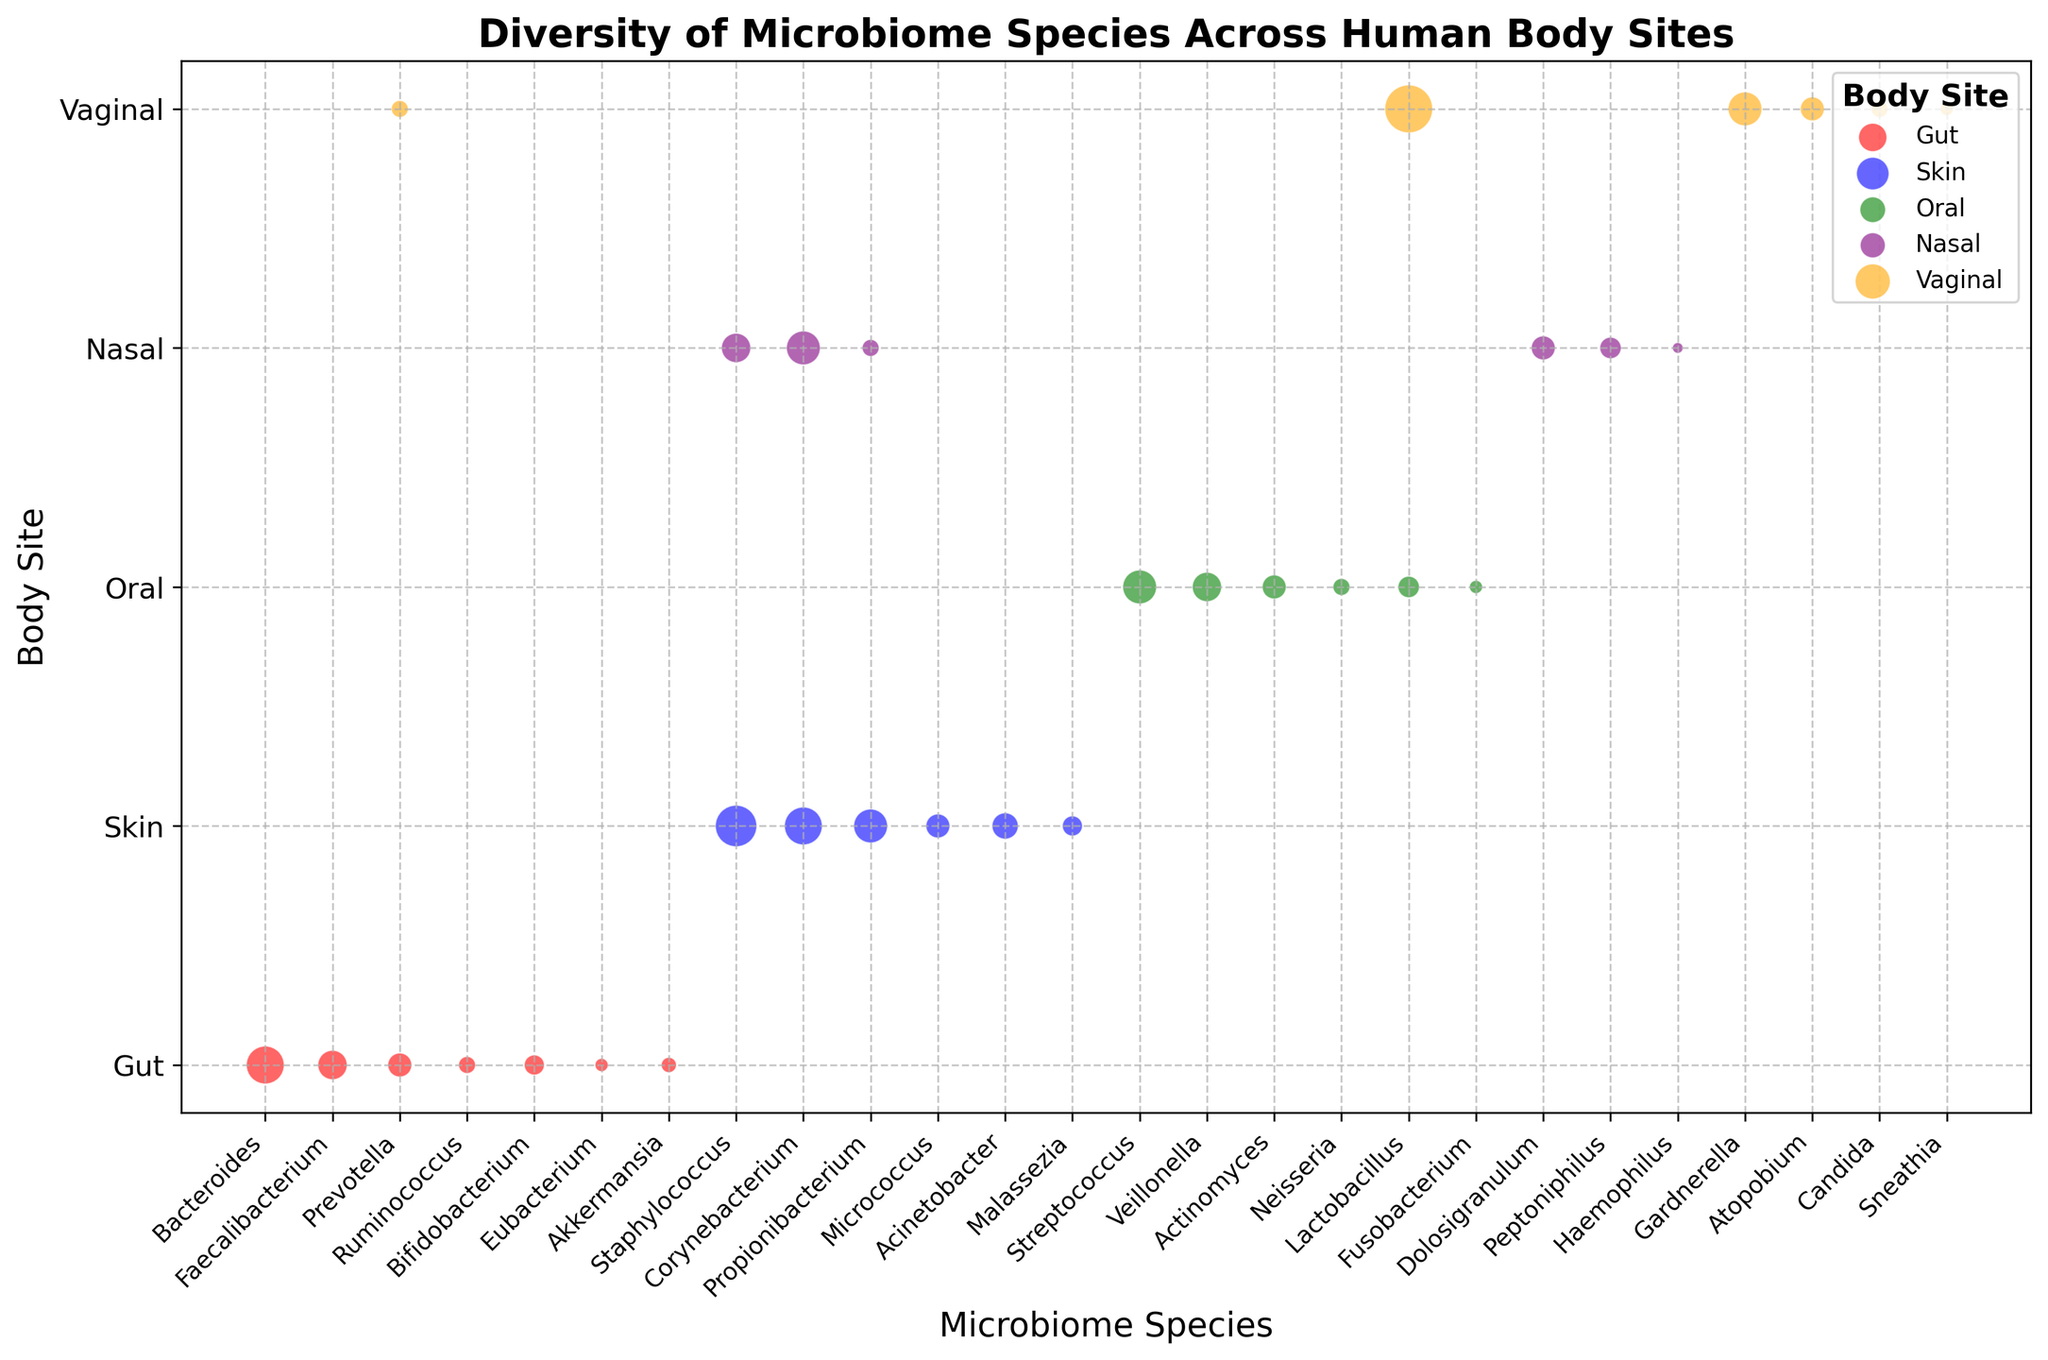What is the microbiome species with the highest relative abundance in the vaginal site? To find the microbiome species with the highest relative abundance in the vaginal site, check the vaginal site on the y-axis and compare the size of the bubbles. Lactobacillus has the largest bubble.
Answer: Lactobacillus Which body site has the most diversity in microbiome species, and how can you tell? Look at the number of different microbiome species listed for each body site on the y-axis. The Gut has the most unique labels, indicating the highest diversity.
Answer: Gut Compare the relative abundance of Staphylococcus in the nasal and skin sites. Which has a higher relative abundance and by how much? Find the bubbles for Staphylococcus in both the nasal and skin sites. The size of the bubble in the skin site (30%) is larger than in the nasal site (15%). The difference is 30% - 15% = 15%.
Answer: Skin by 15% What is the average relative abundance of Propionibacterium across all body sites it appears in? Check the relative abundance of Propionibacterium in each body site (skin and nasal). Sum these values and divide by the number of instances: (20% + 5%) / 2 = 12.5%.
Answer: 12.5% Which body site has the smallest range of relative abundance among its microbiome species? Calculate the range of relative abundance (max - min) for each body site, then compare. For the nasal site, the relative abundance ranges from 2% to 20%, the smallest range of 18%.
Answer: Nasal How does the relative abundance of Faecalibacterium in the gut compare to Veillonella in the oral site? Check the size of the bubbles for Faecalibacterium in the gut (15%) and Veillonella in the oral site (15%). They both have the same relative abundance.
Answer: Equal What is the total relative abundance of microbiome species with over 20% relative abundance? Identify microbiome species with more than 20% relative abundance and sum their values: Staphylococcus (30%), Corynebacterium (25%), Lactobacillus (40%). Total is 30% + 25% + 40% = 95%.
Answer: 95% Which microbiome species appears in the most body sites? Count the number of body sites for each microbiome species. Corynebacterium appears in skin and nasal, making it the one that appears the most (in two sites).
Answer: Corynebacterium 